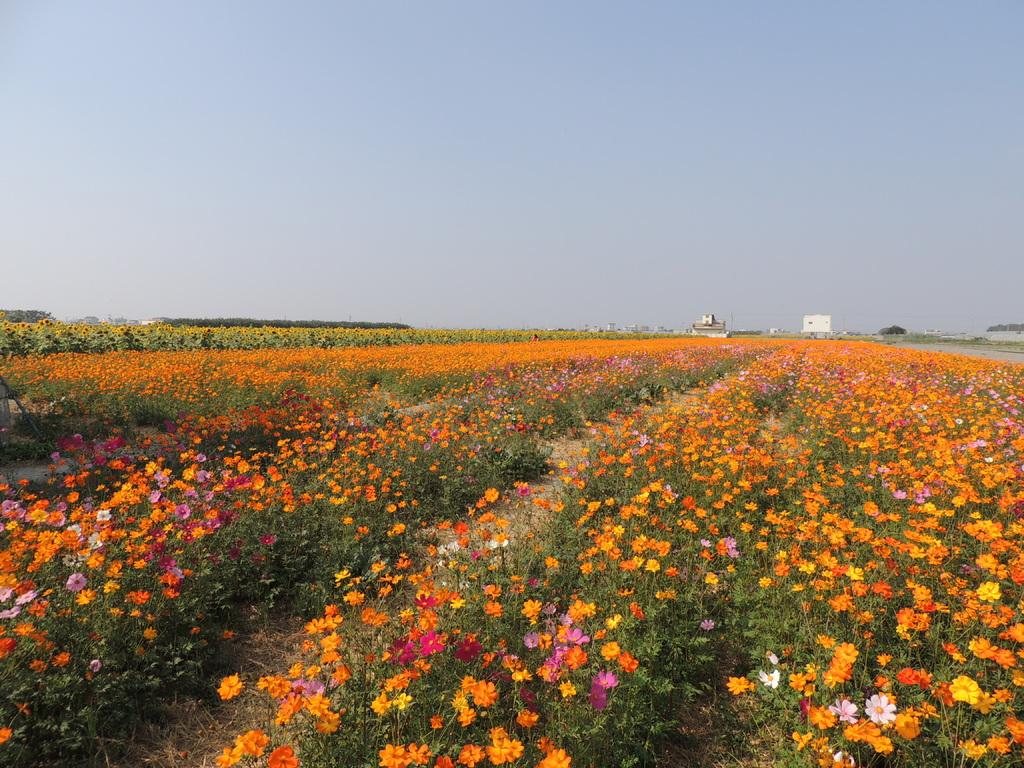What types of vegetation are in the middle of the image? There are flowers and plants in the middle of the image. What can be seen in the background of the image? There are buildings visible in the background of the image. What is visible at the top of the image? The sky is visible at the top of the image. How many frogs are sitting on the stocking in the image? There are no frogs or stockings present in the image. What type of knife is being used to cut the plants in the image? There is no knife or cutting activity depicted in the image; it features flowers and plants in the middle of the image. 